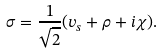Convert formula to latex. <formula><loc_0><loc_0><loc_500><loc_500>\sigma = \frac { 1 } { \sqrt { 2 } } ( v _ { s } + \rho + i \chi ) .</formula> 